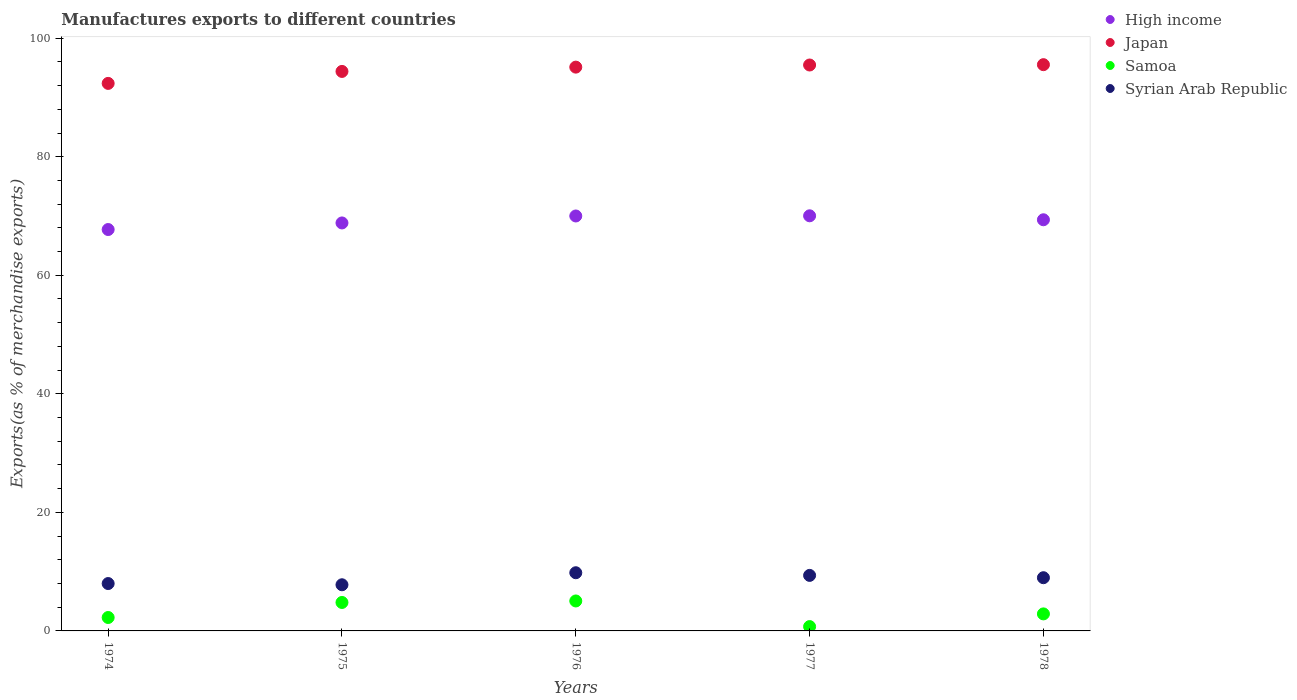How many different coloured dotlines are there?
Make the answer very short. 4. What is the percentage of exports to different countries in High income in 1976?
Make the answer very short. 70. Across all years, what is the maximum percentage of exports to different countries in Japan?
Keep it short and to the point. 95.53. Across all years, what is the minimum percentage of exports to different countries in Japan?
Your answer should be very brief. 92.37. In which year was the percentage of exports to different countries in High income maximum?
Keep it short and to the point. 1977. In which year was the percentage of exports to different countries in High income minimum?
Provide a short and direct response. 1974. What is the total percentage of exports to different countries in Samoa in the graph?
Your response must be concise. 15.72. What is the difference between the percentage of exports to different countries in Syrian Arab Republic in 1975 and that in 1978?
Provide a short and direct response. -1.19. What is the difference between the percentage of exports to different countries in Japan in 1976 and the percentage of exports to different countries in Samoa in 1974?
Your response must be concise. 92.85. What is the average percentage of exports to different countries in Samoa per year?
Your response must be concise. 3.14. In the year 1974, what is the difference between the percentage of exports to different countries in Samoa and percentage of exports to different countries in High income?
Your answer should be very brief. -65.46. In how many years, is the percentage of exports to different countries in Syrian Arab Republic greater than 52 %?
Your answer should be compact. 0. What is the ratio of the percentage of exports to different countries in Syrian Arab Republic in 1974 to that in 1978?
Give a very brief answer. 0.89. What is the difference between the highest and the second highest percentage of exports to different countries in High income?
Your answer should be compact. 0.03. What is the difference between the highest and the lowest percentage of exports to different countries in Samoa?
Your response must be concise. 4.32. In how many years, is the percentage of exports to different countries in Japan greater than the average percentage of exports to different countries in Japan taken over all years?
Your answer should be compact. 3. Is the sum of the percentage of exports to different countries in Japan in 1974 and 1977 greater than the maximum percentage of exports to different countries in Syrian Arab Republic across all years?
Your answer should be very brief. Yes. Is it the case that in every year, the sum of the percentage of exports to different countries in Syrian Arab Republic and percentage of exports to different countries in High income  is greater than the sum of percentage of exports to different countries in Japan and percentage of exports to different countries in Samoa?
Your response must be concise. No. Is the percentage of exports to different countries in Syrian Arab Republic strictly greater than the percentage of exports to different countries in Samoa over the years?
Make the answer very short. Yes. Is the percentage of exports to different countries in Syrian Arab Republic strictly less than the percentage of exports to different countries in Samoa over the years?
Your answer should be very brief. No. What is the difference between two consecutive major ticks on the Y-axis?
Your answer should be very brief. 20. Are the values on the major ticks of Y-axis written in scientific E-notation?
Your answer should be compact. No. Does the graph contain any zero values?
Give a very brief answer. No. Does the graph contain grids?
Ensure brevity in your answer.  No. What is the title of the graph?
Give a very brief answer. Manufactures exports to different countries. Does "Iraq" appear as one of the legend labels in the graph?
Offer a very short reply. No. What is the label or title of the X-axis?
Offer a terse response. Years. What is the label or title of the Y-axis?
Offer a terse response. Exports(as % of merchandise exports). What is the Exports(as % of merchandise exports) of High income in 1974?
Keep it short and to the point. 67.72. What is the Exports(as % of merchandise exports) of Japan in 1974?
Provide a short and direct response. 92.37. What is the Exports(as % of merchandise exports) in Samoa in 1974?
Ensure brevity in your answer.  2.26. What is the Exports(as % of merchandise exports) in Syrian Arab Republic in 1974?
Give a very brief answer. 7.99. What is the Exports(as % of merchandise exports) in High income in 1975?
Offer a very short reply. 68.83. What is the Exports(as % of merchandise exports) in Japan in 1975?
Offer a terse response. 94.39. What is the Exports(as % of merchandise exports) in Samoa in 1975?
Your answer should be very brief. 4.8. What is the Exports(as % of merchandise exports) of Syrian Arab Republic in 1975?
Your answer should be very brief. 7.79. What is the Exports(as % of merchandise exports) of High income in 1976?
Make the answer very short. 70. What is the Exports(as % of merchandise exports) of Japan in 1976?
Give a very brief answer. 95.12. What is the Exports(as % of merchandise exports) of Samoa in 1976?
Ensure brevity in your answer.  5.06. What is the Exports(as % of merchandise exports) in Syrian Arab Republic in 1976?
Provide a succinct answer. 9.82. What is the Exports(as % of merchandise exports) of High income in 1977?
Keep it short and to the point. 70.03. What is the Exports(as % of merchandise exports) in Japan in 1977?
Provide a succinct answer. 95.48. What is the Exports(as % of merchandise exports) in Samoa in 1977?
Your response must be concise. 0.73. What is the Exports(as % of merchandise exports) of Syrian Arab Republic in 1977?
Your answer should be compact. 9.37. What is the Exports(as % of merchandise exports) in High income in 1978?
Your response must be concise. 69.37. What is the Exports(as % of merchandise exports) of Japan in 1978?
Give a very brief answer. 95.53. What is the Exports(as % of merchandise exports) of Samoa in 1978?
Provide a short and direct response. 2.87. What is the Exports(as % of merchandise exports) in Syrian Arab Republic in 1978?
Keep it short and to the point. 8.98. Across all years, what is the maximum Exports(as % of merchandise exports) of High income?
Provide a succinct answer. 70.03. Across all years, what is the maximum Exports(as % of merchandise exports) of Japan?
Your answer should be compact. 95.53. Across all years, what is the maximum Exports(as % of merchandise exports) in Samoa?
Offer a very short reply. 5.06. Across all years, what is the maximum Exports(as % of merchandise exports) of Syrian Arab Republic?
Provide a succinct answer. 9.82. Across all years, what is the minimum Exports(as % of merchandise exports) of High income?
Your answer should be very brief. 67.72. Across all years, what is the minimum Exports(as % of merchandise exports) in Japan?
Your response must be concise. 92.37. Across all years, what is the minimum Exports(as % of merchandise exports) of Samoa?
Ensure brevity in your answer.  0.73. Across all years, what is the minimum Exports(as % of merchandise exports) in Syrian Arab Republic?
Your answer should be very brief. 7.79. What is the total Exports(as % of merchandise exports) of High income in the graph?
Provide a short and direct response. 345.95. What is the total Exports(as % of merchandise exports) in Japan in the graph?
Keep it short and to the point. 472.89. What is the total Exports(as % of merchandise exports) of Samoa in the graph?
Your answer should be compact. 15.72. What is the total Exports(as % of merchandise exports) of Syrian Arab Republic in the graph?
Ensure brevity in your answer.  43.94. What is the difference between the Exports(as % of merchandise exports) of High income in 1974 and that in 1975?
Offer a terse response. -1.11. What is the difference between the Exports(as % of merchandise exports) in Japan in 1974 and that in 1975?
Keep it short and to the point. -2.02. What is the difference between the Exports(as % of merchandise exports) in Samoa in 1974 and that in 1975?
Keep it short and to the point. -2.54. What is the difference between the Exports(as % of merchandise exports) of Syrian Arab Republic in 1974 and that in 1975?
Ensure brevity in your answer.  0.21. What is the difference between the Exports(as % of merchandise exports) of High income in 1974 and that in 1976?
Your answer should be very brief. -2.29. What is the difference between the Exports(as % of merchandise exports) of Japan in 1974 and that in 1976?
Provide a short and direct response. -2.74. What is the difference between the Exports(as % of merchandise exports) of Samoa in 1974 and that in 1976?
Ensure brevity in your answer.  -2.79. What is the difference between the Exports(as % of merchandise exports) in Syrian Arab Republic in 1974 and that in 1976?
Provide a short and direct response. -1.82. What is the difference between the Exports(as % of merchandise exports) in High income in 1974 and that in 1977?
Provide a short and direct response. -2.32. What is the difference between the Exports(as % of merchandise exports) of Japan in 1974 and that in 1977?
Provide a succinct answer. -3.1. What is the difference between the Exports(as % of merchandise exports) of Samoa in 1974 and that in 1977?
Provide a succinct answer. 1.53. What is the difference between the Exports(as % of merchandise exports) in Syrian Arab Republic in 1974 and that in 1977?
Give a very brief answer. -1.38. What is the difference between the Exports(as % of merchandise exports) of High income in 1974 and that in 1978?
Offer a terse response. -1.65. What is the difference between the Exports(as % of merchandise exports) of Japan in 1974 and that in 1978?
Your response must be concise. -3.16. What is the difference between the Exports(as % of merchandise exports) of Samoa in 1974 and that in 1978?
Your answer should be compact. -0.61. What is the difference between the Exports(as % of merchandise exports) in Syrian Arab Republic in 1974 and that in 1978?
Provide a succinct answer. -0.98. What is the difference between the Exports(as % of merchandise exports) in High income in 1975 and that in 1976?
Provide a succinct answer. -1.17. What is the difference between the Exports(as % of merchandise exports) of Japan in 1975 and that in 1976?
Your answer should be very brief. -0.73. What is the difference between the Exports(as % of merchandise exports) of Samoa in 1975 and that in 1976?
Provide a short and direct response. -0.26. What is the difference between the Exports(as % of merchandise exports) of Syrian Arab Republic in 1975 and that in 1976?
Ensure brevity in your answer.  -2.03. What is the difference between the Exports(as % of merchandise exports) of High income in 1975 and that in 1977?
Ensure brevity in your answer.  -1.2. What is the difference between the Exports(as % of merchandise exports) of Japan in 1975 and that in 1977?
Provide a short and direct response. -1.08. What is the difference between the Exports(as % of merchandise exports) in Samoa in 1975 and that in 1977?
Provide a succinct answer. 4.07. What is the difference between the Exports(as % of merchandise exports) of Syrian Arab Republic in 1975 and that in 1977?
Your response must be concise. -1.58. What is the difference between the Exports(as % of merchandise exports) of High income in 1975 and that in 1978?
Your response must be concise. -0.54. What is the difference between the Exports(as % of merchandise exports) in Japan in 1975 and that in 1978?
Provide a short and direct response. -1.14. What is the difference between the Exports(as % of merchandise exports) in Samoa in 1975 and that in 1978?
Offer a very short reply. 1.93. What is the difference between the Exports(as % of merchandise exports) in Syrian Arab Republic in 1975 and that in 1978?
Make the answer very short. -1.19. What is the difference between the Exports(as % of merchandise exports) of High income in 1976 and that in 1977?
Give a very brief answer. -0.03. What is the difference between the Exports(as % of merchandise exports) in Japan in 1976 and that in 1977?
Offer a very short reply. -0.36. What is the difference between the Exports(as % of merchandise exports) in Samoa in 1976 and that in 1977?
Provide a succinct answer. 4.32. What is the difference between the Exports(as % of merchandise exports) in Syrian Arab Republic in 1976 and that in 1977?
Offer a terse response. 0.45. What is the difference between the Exports(as % of merchandise exports) in High income in 1976 and that in 1978?
Provide a succinct answer. 0.64. What is the difference between the Exports(as % of merchandise exports) of Japan in 1976 and that in 1978?
Keep it short and to the point. -0.41. What is the difference between the Exports(as % of merchandise exports) in Samoa in 1976 and that in 1978?
Provide a short and direct response. 2.18. What is the difference between the Exports(as % of merchandise exports) of Syrian Arab Republic in 1976 and that in 1978?
Ensure brevity in your answer.  0.84. What is the difference between the Exports(as % of merchandise exports) of High income in 1977 and that in 1978?
Give a very brief answer. 0.67. What is the difference between the Exports(as % of merchandise exports) in Japan in 1977 and that in 1978?
Offer a terse response. -0.06. What is the difference between the Exports(as % of merchandise exports) of Samoa in 1977 and that in 1978?
Ensure brevity in your answer.  -2.14. What is the difference between the Exports(as % of merchandise exports) in Syrian Arab Republic in 1977 and that in 1978?
Offer a very short reply. 0.39. What is the difference between the Exports(as % of merchandise exports) in High income in 1974 and the Exports(as % of merchandise exports) in Japan in 1975?
Ensure brevity in your answer.  -26.67. What is the difference between the Exports(as % of merchandise exports) in High income in 1974 and the Exports(as % of merchandise exports) in Samoa in 1975?
Offer a terse response. 62.92. What is the difference between the Exports(as % of merchandise exports) in High income in 1974 and the Exports(as % of merchandise exports) in Syrian Arab Republic in 1975?
Offer a very short reply. 59.93. What is the difference between the Exports(as % of merchandise exports) of Japan in 1974 and the Exports(as % of merchandise exports) of Samoa in 1975?
Provide a short and direct response. 87.57. What is the difference between the Exports(as % of merchandise exports) in Japan in 1974 and the Exports(as % of merchandise exports) in Syrian Arab Republic in 1975?
Provide a succinct answer. 84.59. What is the difference between the Exports(as % of merchandise exports) in Samoa in 1974 and the Exports(as % of merchandise exports) in Syrian Arab Republic in 1975?
Your answer should be compact. -5.52. What is the difference between the Exports(as % of merchandise exports) in High income in 1974 and the Exports(as % of merchandise exports) in Japan in 1976?
Your response must be concise. -27.4. What is the difference between the Exports(as % of merchandise exports) in High income in 1974 and the Exports(as % of merchandise exports) in Samoa in 1976?
Offer a very short reply. 62.66. What is the difference between the Exports(as % of merchandise exports) of High income in 1974 and the Exports(as % of merchandise exports) of Syrian Arab Republic in 1976?
Your answer should be very brief. 57.9. What is the difference between the Exports(as % of merchandise exports) of Japan in 1974 and the Exports(as % of merchandise exports) of Samoa in 1976?
Your answer should be very brief. 87.32. What is the difference between the Exports(as % of merchandise exports) in Japan in 1974 and the Exports(as % of merchandise exports) in Syrian Arab Republic in 1976?
Ensure brevity in your answer.  82.56. What is the difference between the Exports(as % of merchandise exports) in Samoa in 1974 and the Exports(as % of merchandise exports) in Syrian Arab Republic in 1976?
Your answer should be very brief. -7.55. What is the difference between the Exports(as % of merchandise exports) in High income in 1974 and the Exports(as % of merchandise exports) in Japan in 1977?
Your answer should be very brief. -27.76. What is the difference between the Exports(as % of merchandise exports) in High income in 1974 and the Exports(as % of merchandise exports) in Samoa in 1977?
Give a very brief answer. 66.99. What is the difference between the Exports(as % of merchandise exports) of High income in 1974 and the Exports(as % of merchandise exports) of Syrian Arab Republic in 1977?
Give a very brief answer. 58.35. What is the difference between the Exports(as % of merchandise exports) of Japan in 1974 and the Exports(as % of merchandise exports) of Samoa in 1977?
Offer a terse response. 91.64. What is the difference between the Exports(as % of merchandise exports) of Japan in 1974 and the Exports(as % of merchandise exports) of Syrian Arab Republic in 1977?
Provide a short and direct response. 83.01. What is the difference between the Exports(as % of merchandise exports) of Samoa in 1974 and the Exports(as % of merchandise exports) of Syrian Arab Republic in 1977?
Provide a short and direct response. -7.1. What is the difference between the Exports(as % of merchandise exports) in High income in 1974 and the Exports(as % of merchandise exports) in Japan in 1978?
Offer a very short reply. -27.81. What is the difference between the Exports(as % of merchandise exports) in High income in 1974 and the Exports(as % of merchandise exports) in Samoa in 1978?
Your answer should be very brief. 64.85. What is the difference between the Exports(as % of merchandise exports) in High income in 1974 and the Exports(as % of merchandise exports) in Syrian Arab Republic in 1978?
Your response must be concise. 58.74. What is the difference between the Exports(as % of merchandise exports) in Japan in 1974 and the Exports(as % of merchandise exports) in Samoa in 1978?
Offer a very short reply. 89.5. What is the difference between the Exports(as % of merchandise exports) in Japan in 1974 and the Exports(as % of merchandise exports) in Syrian Arab Republic in 1978?
Provide a short and direct response. 83.4. What is the difference between the Exports(as % of merchandise exports) in Samoa in 1974 and the Exports(as % of merchandise exports) in Syrian Arab Republic in 1978?
Give a very brief answer. -6.71. What is the difference between the Exports(as % of merchandise exports) of High income in 1975 and the Exports(as % of merchandise exports) of Japan in 1976?
Offer a very short reply. -26.29. What is the difference between the Exports(as % of merchandise exports) of High income in 1975 and the Exports(as % of merchandise exports) of Samoa in 1976?
Give a very brief answer. 63.78. What is the difference between the Exports(as % of merchandise exports) in High income in 1975 and the Exports(as % of merchandise exports) in Syrian Arab Republic in 1976?
Provide a short and direct response. 59.01. What is the difference between the Exports(as % of merchandise exports) of Japan in 1975 and the Exports(as % of merchandise exports) of Samoa in 1976?
Ensure brevity in your answer.  89.34. What is the difference between the Exports(as % of merchandise exports) of Japan in 1975 and the Exports(as % of merchandise exports) of Syrian Arab Republic in 1976?
Your response must be concise. 84.58. What is the difference between the Exports(as % of merchandise exports) in Samoa in 1975 and the Exports(as % of merchandise exports) in Syrian Arab Republic in 1976?
Offer a very short reply. -5.02. What is the difference between the Exports(as % of merchandise exports) of High income in 1975 and the Exports(as % of merchandise exports) of Japan in 1977?
Provide a short and direct response. -26.65. What is the difference between the Exports(as % of merchandise exports) in High income in 1975 and the Exports(as % of merchandise exports) in Samoa in 1977?
Keep it short and to the point. 68.1. What is the difference between the Exports(as % of merchandise exports) of High income in 1975 and the Exports(as % of merchandise exports) of Syrian Arab Republic in 1977?
Provide a short and direct response. 59.46. What is the difference between the Exports(as % of merchandise exports) of Japan in 1975 and the Exports(as % of merchandise exports) of Samoa in 1977?
Provide a short and direct response. 93.66. What is the difference between the Exports(as % of merchandise exports) in Japan in 1975 and the Exports(as % of merchandise exports) in Syrian Arab Republic in 1977?
Your answer should be very brief. 85.02. What is the difference between the Exports(as % of merchandise exports) in Samoa in 1975 and the Exports(as % of merchandise exports) in Syrian Arab Republic in 1977?
Ensure brevity in your answer.  -4.57. What is the difference between the Exports(as % of merchandise exports) of High income in 1975 and the Exports(as % of merchandise exports) of Japan in 1978?
Your answer should be very brief. -26.7. What is the difference between the Exports(as % of merchandise exports) in High income in 1975 and the Exports(as % of merchandise exports) in Samoa in 1978?
Ensure brevity in your answer.  65.96. What is the difference between the Exports(as % of merchandise exports) of High income in 1975 and the Exports(as % of merchandise exports) of Syrian Arab Republic in 1978?
Provide a succinct answer. 59.85. What is the difference between the Exports(as % of merchandise exports) in Japan in 1975 and the Exports(as % of merchandise exports) in Samoa in 1978?
Make the answer very short. 91.52. What is the difference between the Exports(as % of merchandise exports) of Japan in 1975 and the Exports(as % of merchandise exports) of Syrian Arab Republic in 1978?
Your answer should be compact. 85.41. What is the difference between the Exports(as % of merchandise exports) of Samoa in 1975 and the Exports(as % of merchandise exports) of Syrian Arab Republic in 1978?
Keep it short and to the point. -4.18. What is the difference between the Exports(as % of merchandise exports) of High income in 1976 and the Exports(as % of merchandise exports) of Japan in 1977?
Provide a succinct answer. -25.47. What is the difference between the Exports(as % of merchandise exports) in High income in 1976 and the Exports(as % of merchandise exports) in Samoa in 1977?
Provide a short and direct response. 69.27. What is the difference between the Exports(as % of merchandise exports) in High income in 1976 and the Exports(as % of merchandise exports) in Syrian Arab Republic in 1977?
Offer a very short reply. 60.64. What is the difference between the Exports(as % of merchandise exports) in Japan in 1976 and the Exports(as % of merchandise exports) in Samoa in 1977?
Your response must be concise. 94.39. What is the difference between the Exports(as % of merchandise exports) in Japan in 1976 and the Exports(as % of merchandise exports) in Syrian Arab Republic in 1977?
Provide a short and direct response. 85.75. What is the difference between the Exports(as % of merchandise exports) of Samoa in 1976 and the Exports(as % of merchandise exports) of Syrian Arab Republic in 1977?
Provide a short and direct response. -4.31. What is the difference between the Exports(as % of merchandise exports) of High income in 1976 and the Exports(as % of merchandise exports) of Japan in 1978?
Ensure brevity in your answer.  -25.53. What is the difference between the Exports(as % of merchandise exports) in High income in 1976 and the Exports(as % of merchandise exports) in Samoa in 1978?
Offer a terse response. 67.13. What is the difference between the Exports(as % of merchandise exports) in High income in 1976 and the Exports(as % of merchandise exports) in Syrian Arab Republic in 1978?
Provide a succinct answer. 61.03. What is the difference between the Exports(as % of merchandise exports) in Japan in 1976 and the Exports(as % of merchandise exports) in Samoa in 1978?
Offer a very short reply. 92.25. What is the difference between the Exports(as % of merchandise exports) in Japan in 1976 and the Exports(as % of merchandise exports) in Syrian Arab Republic in 1978?
Your answer should be compact. 86.14. What is the difference between the Exports(as % of merchandise exports) of Samoa in 1976 and the Exports(as % of merchandise exports) of Syrian Arab Republic in 1978?
Your response must be concise. -3.92. What is the difference between the Exports(as % of merchandise exports) of High income in 1977 and the Exports(as % of merchandise exports) of Japan in 1978?
Offer a terse response. -25.5. What is the difference between the Exports(as % of merchandise exports) in High income in 1977 and the Exports(as % of merchandise exports) in Samoa in 1978?
Provide a short and direct response. 67.16. What is the difference between the Exports(as % of merchandise exports) of High income in 1977 and the Exports(as % of merchandise exports) of Syrian Arab Republic in 1978?
Offer a terse response. 61.06. What is the difference between the Exports(as % of merchandise exports) in Japan in 1977 and the Exports(as % of merchandise exports) in Samoa in 1978?
Provide a short and direct response. 92.6. What is the difference between the Exports(as % of merchandise exports) of Japan in 1977 and the Exports(as % of merchandise exports) of Syrian Arab Republic in 1978?
Provide a succinct answer. 86.5. What is the difference between the Exports(as % of merchandise exports) of Samoa in 1977 and the Exports(as % of merchandise exports) of Syrian Arab Republic in 1978?
Make the answer very short. -8.25. What is the average Exports(as % of merchandise exports) of High income per year?
Make the answer very short. 69.19. What is the average Exports(as % of merchandise exports) of Japan per year?
Your answer should be very brief. 94.58. What is the average Exports(as % of merchandise exports) in Samoa per year?
Offer a very short reply. 3.14. What is the average Exports(as % of merchandise exports) in Syrian Arab Republic per year?
Give a very brief answer. 8.79. In the year 1974, what is the difference between the Exports(as % of merchandise exports) of High income and Exports(as % of merchandise exports) of Japan?
Your response must be concise. -24.65. In the year 1974, what is the difference between the Exports(as % of merchandise exports) in High income and Exports(as % of merchandise exports) in Samoa?
Make the answer very short. 65.46. In the year 1974, what is the difference between the Exports(as % of merchandise exports) of High income and Exports(as % of merchandise exports) of Syrian Arab Republic?
Your answer should be compact. 59.73. In the year 1974, what is the difference between the Exports(as % of merchandise exports) in Japan and Exports(as % of merchandise exports) in Samoa?
Make the answer very short. 90.11. In the year 1974, what is the difference between the Exports(as % of merchandise exports) of Japan and Exports(as % of merchandise exports) of Syrian Arab Republic?
Your response must be concise. 84.38. In the year 1974, what is the difference between the Exports(as % of merchandise exports) of Samoa and Exports(as % of merchandise exports) of Syrian Arab Republic?
Make the answer very short. -5.73. In the year 1975, what is the difference between the Exports(as % of merchandise exports) of High income and Exports(as % of merchandise exports) of Japan?
Ensure brevity in your answer.  -25.56. In the year 1975, what is the difference between the Exports(as % of merchandise exports) in High income and Exports(as % of merchandise exports) in Samoa?
Make the answer very short. 64.03. In the year 1975, what is the difference between the Exports(as % of merchandise exports) of High income and Exports(as % of merchandise exports) of Syrian Arab Republic?
Ensure brevity in your answer.  61.04. In the year 1975, what is the difference between the Exports(as % of merchandise exports) in Japan and Exports(as % of merchandise exports) in Samoa?
Ensure brevity in your answer.  89.59. In the year 1975, what is the difference between the Exports(as % of merchandise exports) in Japan and Exports(as % of merchandise exports) in Syrian Arab Republic?
Provide a short and direct response. 86.61. In the year 1975, what is the difference between the Exports(as % of merchandise exports) in Samoa and Exports(as % of merchandise exports) in Syrian Arab Republic?
Offer a very short reply. -2.99. In the year 1976, what is the difference between the Exports(as % of merchandise exports) of High income and Exports(as % of merchandise exports) of Japan?
Give a very brief answer. -25.11. In the year 1976, what is the difference between the Exports(as % of merchandise exports) of High income and Exports(as % of merchandise exports) of Samoa?
Offer a very short reply. 64.95. In the year 1976, what is the difference between the Exports(as % of merchandise exports) in High income and Exports(as % of merchandise exports) in Syrian Arab Republic?
Your answer should be compact. 60.19. In the year 1976, what is the difference between the Exports(as % of merchandise exports) of Japan and Exports(as % of merchandise exports) of Samoa?
Give a very brief answer. 90.06. In the year 1976, what is the difference between the Exports(as % of merchandise exports) of Japan and Exports(as % of merchandise exports) of Syrian Arab Republic?
Ensure brevity in your answer.  85.3. In the year 1976, what is the difference between the Exports(as % of merchandise exports) in Samoa and Exports(as % of merchandise exports) in Syrian Arab Republic?
Give a very brief answer. -4.76. In the year 1977, what is the difference between the Exports(as % of merchandise exports) in High income and Exports(as % of merchandise exports) in Japan?
Your answer should be very brief. -25.44. In the year 1977, what is the difference between the Exports(as % of merchandise exports) in High income and Exports(as % of merchandise exports) in Samoa?
Your response must be concise. 69.3. In the year 1977, what is the difference between the Exports(as % of merchandise exports) of High income and Exports(as % of merchandise exports) of Syrian Arab Republic?
Ensure brevity in your answer.  60.67. In the year 1977, what is the difference between the Exports(as % of merchandise exports) in Japan and Exports(as % of merchandise exports) in Samoa?
Provide a short and direct response. 94.75. In the year 1977, what is the difference between the Exports(as % of merchandise exports) of Japan and Exports(as % of merchandise exports) of Syrian Arab Republic?
Your response must be concise. 86.11. In the year 1977, what is the difference between the Exports(as % of merchandise exports) of Samoa and Exports(as % of merchandise exports) of Syrian Arab Republic?
Your answer should be compact. -8.64. In the year 1978, what is the difference between the Exports(as % of merchandise exports) of High income and Exports(as % of merchandise exports) of Japan?
Your answer should be very brief. -26.17. In the year 1978, what is the difference between the Exports(as % of merchandise exports) in High income and Exports(as % of merchandise exports) in Samoa?
Your response must be concise. 66.49. In the year 1978, what is the difference between the Exports(as % of merchandise exports) in High income and Exports(as % of merchandise exports) in Syrian Arab Republic?
Offer a very short reply. 60.39. In the year 1978, what is the difference between the Exports(as % of merchandise exports) of Japan and Exports(as % of merchandise exports) of Samoa?
Keep it short and to the point. 92.66. In the year 1978, what is the difference between the Exports(as % of merchandise exports) in Japan and Exports(as % of merchandise exports) in Syrian Arab Republic?
Provide a short and direct response. 86.55. In the year 1978, what is the difference between the Exports(as % of merchandise exports) of Samoa and Exports(as % of merchandise exports) of Syrian Arab Republic?
Your answer should be compact. -6.11. What is the ratio of the Exports(as % of merchandise exports) in High income in 1974 to that in 1975?
Your answer should be compact. 0.98. What is the ratio of the Exports(as % of merchandise exports) of Japan in 1974 to that in 1975?
Make the answer very short. 0.98. What is the ratio of the Exports(as % of merchandise exports) in Samoa in 1974 to that in 1975?
Your answer should be compact. 0.47. What is the ratio of the Exports(as % of merchandise exports) in Syrian Arab Republic in 1974 to that in 1975?
Keep it short and to the point. 1.03. What is the ratio of the Exports(as % of merchandise exports) of High income in 1974 to that in 1976?
Your response must be concise. 0.97. What is the ratio of the Exports(as % of merchandise exports) of Japan in 1974 to that in 1976?
Your response must be concise. 0.97. What is the ratio of the Exports(as % of merchandise exports) in Samoa in 1974 to that in 1976?
Offer a very short reply. 0.45. What is the ratio of the Exports(as % of merchandise exports) in Syrian Arab Republic in 1974 to that in 1976?
Your response must be concise. 0.81. What is the ratio of the Exports(as % of merchandise exports) of High income in 1974 to that in 1977?
Keep it short and to the point. 0.97. What is the ratio of the Exports(as % of merchandise exports) of Japan in 1974 to that in 1977?
Offer a very short reply. 0.97. What is the ratio of the Exports(as % of merchandise exports) in Samoa in 1974 to that in 1977?
Offer a very short reply. 3.1. What is the ratio of the Exports(as % of merchandise exports) in Syrian Arab Republic in 1974 to that in 1977?
Your answer should be compact. 0.85. What is the ratio of the Exports(as % of merchandise exports) of High income in 1974 to that in 1978?
Provide a short and direct response. 0.98. What is the ratio of the Exports(as % of merchandise exports) in Japan in 1974 to that in 1978?
Offer a terse response. 0.97. What is the ratio of the Exports(as % of merchandise exports) in Samoa in 1974 to that in 1978?
Provide a short and direct response. 0.79. What is the ratio of the Exports(as % of merchandise exports) in Syrian Arab Republic in 1974 to that in 1978?
Your answer should be compact. 0.89. What is the ratio of the Exports(as % of merchandise exports) in High income in 1975 to that in 1976?
Provide a short and direct response. 0.98. What is the ratio of the Exports(as % of merchandise exports) of Samoa in 1975 to that in 1976?
Your answer should be compact. 0.95. What is the ratio of the Exports(as % of merchandise exports) of Syrian Arab Republic in 1975 to that in 1976?
Provide a short and direct response. 0.79. What is the ratio of the Exports(as % of merchandise exports) in High income in 1975 to that in 1977?
Your answer should be compact. 0.98. What is the ratio of the Exports(as % of merchandise exports) in Japan in 1975 to that in 1977?
Provide a succinct answer. 0.99. What is the ratio of the Exports(as % of merchandise exports) of Samoa in 1975 to that in 1977?
Give a very brief answer. 6.57. What is the ratio of the Exports(as % of merchandise exports) in Syrian Arab Republic in 1975 to that in 1977?
Provide a succinct answer. 0.83. What is the ratio of the Exports(as % of merchandise exports) of High income in 1975 to that in 1978?
Offer a very short reply. 0.99. What is the ratio of the Exports(as % of merchandise exports) of Samoa in 1975 to that in 1978?
Give a very brief answer. 1.67. What is the ratio of the Exports(as % of merchandise exports) of Syrian Arab Republic in 1975 to that in 1978?
Offer a very short reply. 0.87. What is the ratio of the Exports(as % of merchandise exports) of High income in 1976 to that in 1977?
Give a very brief answer. 1. What is the ratio of the Exports(as % of merchandise exports) of Japan in 1976 to that in 1977?
Offer a terse response. 1. What is the ratio of the Exports(as % of merchandise exports) of Samoa in 1976 to that in 1977?
Offer a very short reply. 6.92. What is the ratio of the Exports(as % of merchandise exports) in Syrian Arab Republic in 1976 to that in 1977?
Ensure brevity in your answer.  1.05. What is the ratio of the Exports(as % of merchandise exports) of High income in 1976 to that in 1978?
Give a very brief answer. 1.01. What is the ratio of the Exports(as % of merchandise exports) in Samoa in 1976 to that in 1978?
Your answer should be very brief. 1.76. What is the ratio of the Exports(as % of merchandise exports) of Syrian Arab Republic in 1976 to that in 1978?
Give a very brief answer. 1.09. What is the ratio of the Exports(as % of merchandise exports) in High income in 1977 to that in 1978?
Give a very brief answer. 1.01. What is the ratio of the Exports(as % of merchandise exports) in Japan in 1977 to that in 1978?
Your response must be concise. 1. What is the ratio of the Exports(as % of merchandise exports) in Samoa in 1977 to that in 1978?
Make the answer very short. 0.25. What is the ratio of the Exports(as % of merchandise exports) in Syrian Arab Republic in 1977 to that in 1978?
Keep it short and to the point. 1.04. What is the difference between the highest and the second highest Exports(as % of merchandise exports) in High income?
Ensure brevity in your answer.  0.03. What is the difference between the highest and the second highest Exports(as % of merchandise exports) of Japan?
Your answer should be compact. 0.06. What is the difference between the highest and the second highest Exports(as % of merchandise exports) of Samoa?
Make the answer very short. 0.26. What is the difference between the highest and the second highest Exports(as % of merchandise exports) of Syrian Arab Republic?
Make the answer very short. 0.45. What is the difference between the highest and the lowest Exports(as % of merchandise exports) of High income?
Your response must be concise. 2.32. What is the difference between the highest and the lowest Exports(as % of merchandise exports) of Japan?
Your answer should be very brief. 3.16. What is the difference between the highest and the lowest Exports(as % of merchandise exports) in Samoa?
Your answer should be very brief. 4.32. What is the difference between the highest and the lowest Exports(as % of merchandise exports) in Syrian Arab Republic?
Your answer should be compact. 2.03. 